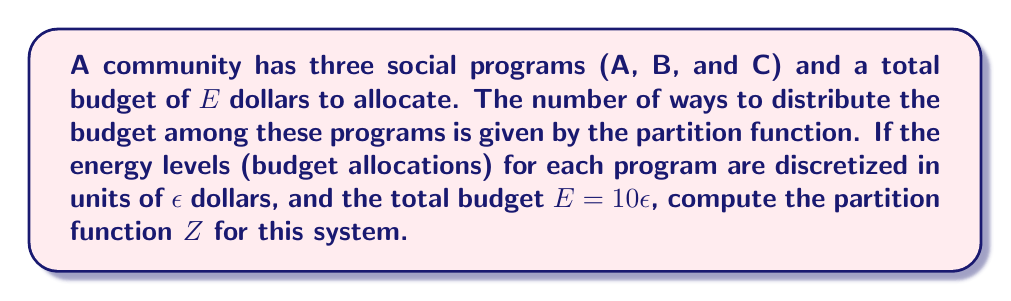Give your solution to this math problem. To solve this problem, we'll follow these steps:

1) The partition function $Z$ for a system with discrete energy levels is given by:
   
   $$Z = \sum_i g_i e^{-\beta E_i}$$

   where $g_i$ is the degeneracy (number of ways to achieve that state) and $E_i$ is the energy of state $i$.

2) In this case, $\beta = 1$ (as we're not considering temperature), and $E_i = i\epsilon$.

3) The degeneracy $g_i$ is the number of ways to distribute $i\epsilon$ dollars among 3 programs. This is equivalent to the number of ways to put $i$ indistinguishable balls into 3 distinguishable boxes, which is given by the "stars and bars" formula:

   $$g_i = \binom{i+2}{2} = \frac{(i+2)(i+1)}{2}$$

4) Now, we can write out our partition function:

   $$Z = \sum_{i=0}^{10} \frac{(i+2)(i+1)}{2} e^{-i\epsilon}$$

5) Expanding this sum:

   $$Z = 1 + 3e^{-\epsilon} + 6e^{-2\epsilon} + 10e^{-3\epsilon} + 15e^{-4\epsilon} + 21e^{-5\epsilon} + 28e^{-6\epsilon} + 36e^{-7\epsilon} + 45e^{-8\epsilon} + 55e^{-9\epsilon} + 66e^{-10\epsilon}$$

This is the final form of our partition function.
Answer: $$Z = \sum_{i=0}^{10} \frac{(i+2)(i+1)}{2} e^{-i\epsilon}$$ 